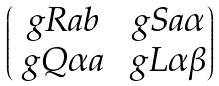<formula> <loc_0><loc_0><loc_500><loc_500>\begin{pmatrix} \ g R { a } { b } & \ g S { a } { \alpha } \\ \ g Q { \alpha } { a } & \ g L { \alpha } { \beta } \end{pmatrix}</formula> 